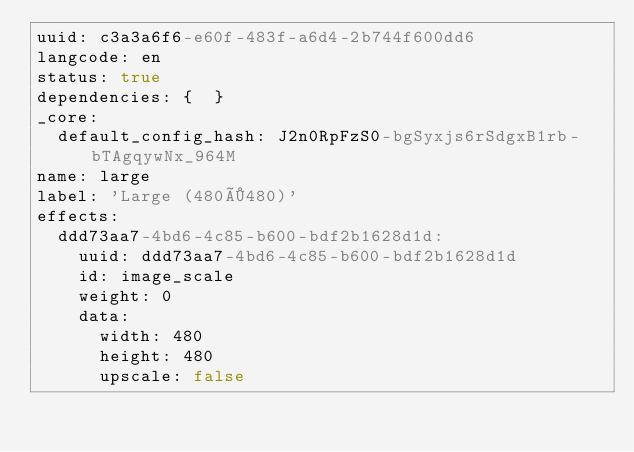<code> <loc_0><loc_0><loc_500><loc_500><_YAML_>uuid: c3a3a6f6-e60f-483f-a6d4-2b744f600dd6
langcode: en
status: true
dependencies: {  }
_core:
  default_config_hash: J2n0RpFzS0-bgSyxjs6rSdgxB1rb-bTAgqywNx_964M
name: large
label: 'Large (480×480)'
effects:
  ddd73aa7-4bd6-4c85-b600-bdf2b1628d1d:
    uuid: ddd73aa7-4bd6-4c85-b600-bdf2b1628d1d
    id: image_scale
    weight: 0
    data:
      width: 480
      height: 480
      upscale: false
</code> 